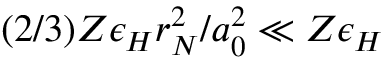Convert formula to latex. <formula><loc_0><loc_0><loc_500><loc_500>( 2 / 3 ) Z \epsilon _ { H } r _ { N } ^ { 2 } / a _ { 0 } ^ { 2 } \ll Z \epsilon _ { H }</formula> 